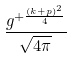Convert formula to latex. <formula><loc_0><loc_0><loc_500><loc_500>\frac { g ^ { + \frac { ( k + p ) ^ { 2 } } { 4 } } } { \sqrt { 4 \pi } }</formula> 